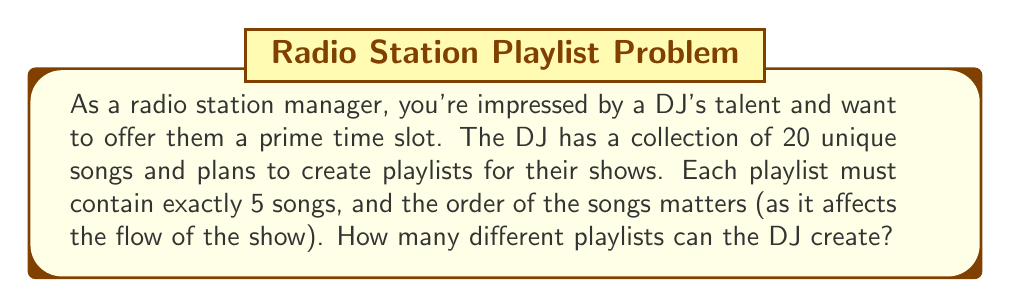Help me with this question. To solve this problem, we need to use the concept of permutations. Since the order of the songs matters and we are selecting 5 songs out of 20 without repetition, this is a permutation problem.

The formula for permutations is:

$$P(n,r) = \frac{n!}{(n-r)!}$$

Where:
$n$ = total number of items to choose from
$r$ = number of items being chosen

In this case:
$n = 20$ (total number of songs)
$r = 5$ (number of songs in each playlist)

Plugging these values into the formula:

$$P(20,5) = \frac{20!}{(20-5)!} = \frac{20!}{15!}$$

Expanding this:

$$\frac{20 \cdot 19 \cdot 18 \cdot 17 \cdot 16 \cdot 15!}{15!}$$

The $15!$ cancels out in the numerator and denominator:

$$20 \cdot 19 \cdot 18 \cdot 17 \cdot 16 = 1,860,480$$

Therefore, the DJ can create 1,860,480 different playlists.
Answer: The DJ can create 1,860,480 unique playlists. 